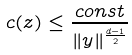Convert formula to latex. <formula><loc_0><loc_0><loc_500><loc_500>c ( z ) \leq \frac { c o n s t } { \| y \| ^ { \frac { d - 1 } { 2 } } }</formula> 